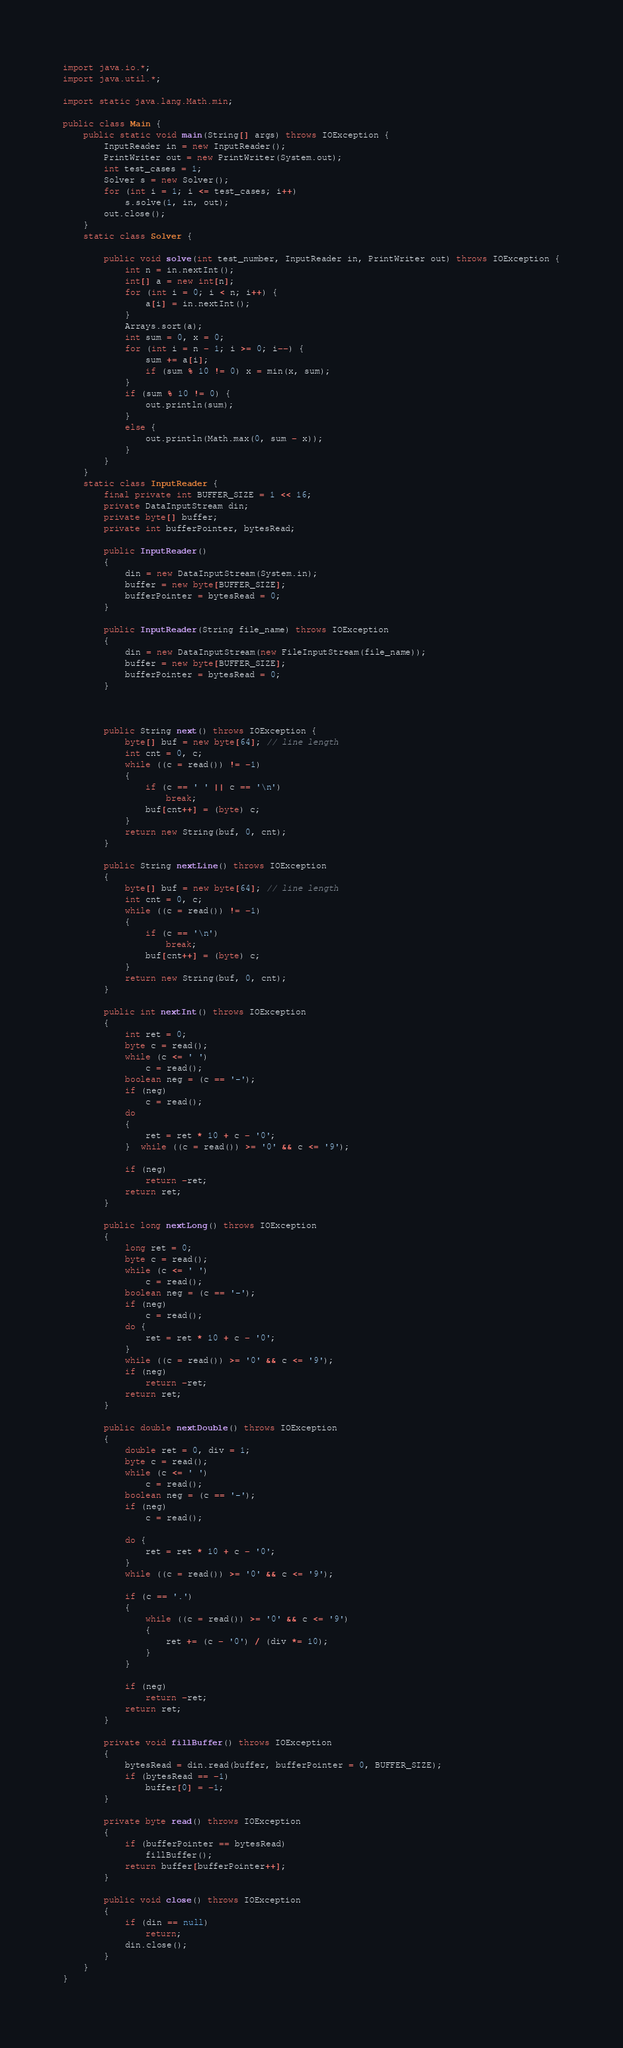Convert code to text. <code><loc_0><loc_0><loc_500><loc_500><_Java_>import java.io.*;
import java.util.*;

import static java.lang.Math.min;

public class Main {
    public static void main(String[] args) throws IOException {
        InputReader in = new InputReader();
        PrintWriter out = new PrintWriter(System.out);
        int test_cases = 1;
        Solver s = new Solver();
        for (int i = 1; i <= test_cases; i++)
            s.solve(1, in, out);
        out.close();
    }
    static class Solver {

        public void solve(int test_number, InputReader in, PrintWriter out) throws IOException {
            int n = in.nextInt();
            int[] a = new int[n];
            for (int i = 0; i < n; i++) {
                a[i] = in.nextInt();
            }
            Arrays.sort(a);
            int sum = 0, x = 0;
            for (int i = n - 1; i >= 0; i--) {
                sum += a[i];
                if (sum % 10 != 0) x = min(x, sum);
            }
            if (sum % 10 != 0) {
                out.println(sum);
            }
            else {
                out.println(Math.max(0, sum - x));
            }
        }
    }
    static class InputReader {
        final private int BUFFER_SIZE = 1 << 16;
        private DataInputStream din;
        private byte[] buffer;
        private int bufferPointer, bytesRead;

        public InputReader()
        {
            din = new DataInputStream(System.in);
            buffer = new byte[BUFFER_SIZE];
            bufferPointer = bytesRead = 0;
        }

        public InputReader(String file_name) throws IOException
        {
            din = new DataInputStream(new FileInputStream(file_name));
            buffer = new byte[BUFFER_SIZE];
            bufferPointer = bytesRead = 0;
        }



        public String next() throws IOException {
            byte[] buf = new byte[64]; // line length
            int cnt = 0, c;
            while ((c = read()) != -1)
            {
                if (c == ' ' || c == '\n')
                    break;
                buf[cnt++] = (byte) c;
            }
            return new String(buf, 0, cnt);
        }

        public String nextLine() throws IOException
        {
            byte[] buf = new byte[64]; // line length
            int cnt = 0, c;
            while ((c = read()) != -1)
            {
                if (c == '\n')
                    break;
                buf[cnt++] = (byte) c;
            }
            return new String(buf, 0, cnt);
        }

        public int nextInt() throws IOException
        {
            int ret = 0;
            byte c = read();
            while (c <= ' ')
                c = read();
            boolean neg = (c == '-');
            if (neg)
                c = read();
            do
            {
                ret = ret * 10 + c - '0';
            }  while ((c = read()) >= '0' && c <= '9');

            if (neg)
                return -ret;
            return ret;
        }

        public long nextLong() throws IOException
        {
            long ret = 0;
            byte c = read();
            while (c <= ' ')
                c = read();
            boolean neg = (c == '-');
            if (neg)
                c = read();
            do {
                ret = ret * 10 + c - '0';
            }
            while ((c = read()) >= '0' && c <= '9');
            if (neg)
                return -ret;
            return ret;
        }

        public double nextDouble() throws IOException
        {
            double ret = 0, div = 1;
            byte c = read();
            while (c <= ' ')
                c = read();
            boolean neg = (c == '-');
            if (neg)
                c = read();

            do {
                ret = ret * 10 + c - '0';
            }
            while ((c = read()) >= '0' && c <= '9');

            if (c == '.')
            {
                while ((c = read()) >= '0' && c <= '9')
                {
                    ret += (c - '0') / (div *= 10);
                }
            }

            if (neg)
                return -ret;
            return ret;
        }

        private void fillBuffer() throws IOException
        {
            bytesRead = din.read(buffer, bufferPointer = 0, BUFFER_SIZE);
            if (bytesRead == -1)
                buffer[0] = -1;
        }

        private byte read() throws IOException
        {
            if (bufferPointer == bytesRead)
                fillBuffer();
            return buffer[bufferPointer++];
        }

        public void close() throws IOException
        {
            if (din == null)
                return;
            din.close();
        }
    }
}</code> 